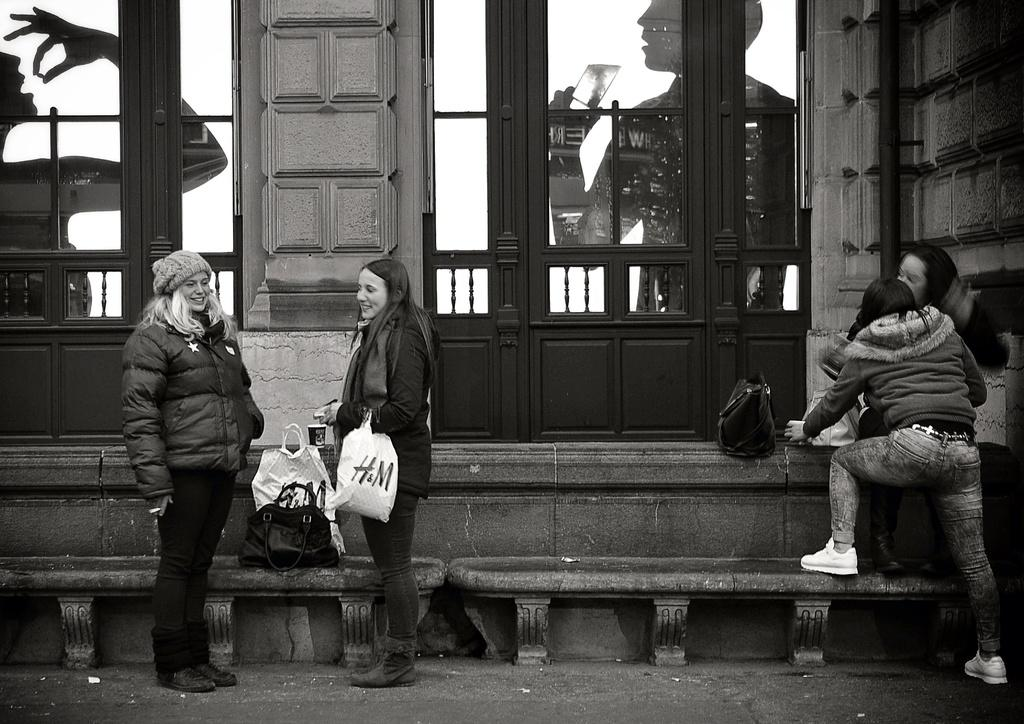How many people are in the image? There are four persons in the image. What objects are visible in the image besides the people? There are bags and benches visible in the image. What type of structure can be seen in the image? There is a building in the image. What is depicted on the posters in the image? The posters in the image show two persons holding objects. What type of pie is being served during the holiday depicted in the image? There is no holiday or pie present in the image; it only shows four persons, bags, benches, a building, and posters. 